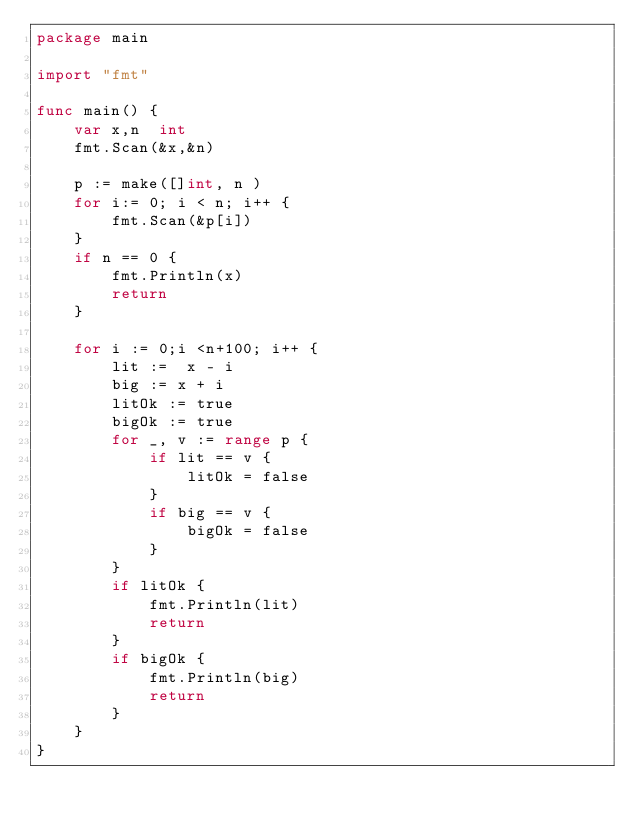Convert code to text. <code><loc_0><loc_0><loc_500><loc_500><_Go_>package main

import "fmt"

func main() {
	var x,n  int
	fmt.Scan(&x,&n)

	p := make([]int, n )
	for i:= 0; i < n; i++ {
		fmt.Scan(&p[i])
	}
	if n == 0 {
		fmt.Println(x)
		return
	}

	for i := 0;i <n+100; i++ {
		lit :=  x - i
		big := x + i
		litOk := true
		bigOk := true
		for _, v := range p {
			if lit == v {
				litOk = false
			}
			if big == v {
				bigOk = false
			}
		}
		if litOk {
			fmt.Println(lit)
			return
		}
		if bigOk {
			fmt.Println(big)
			return
		}
	}
}

</code> 